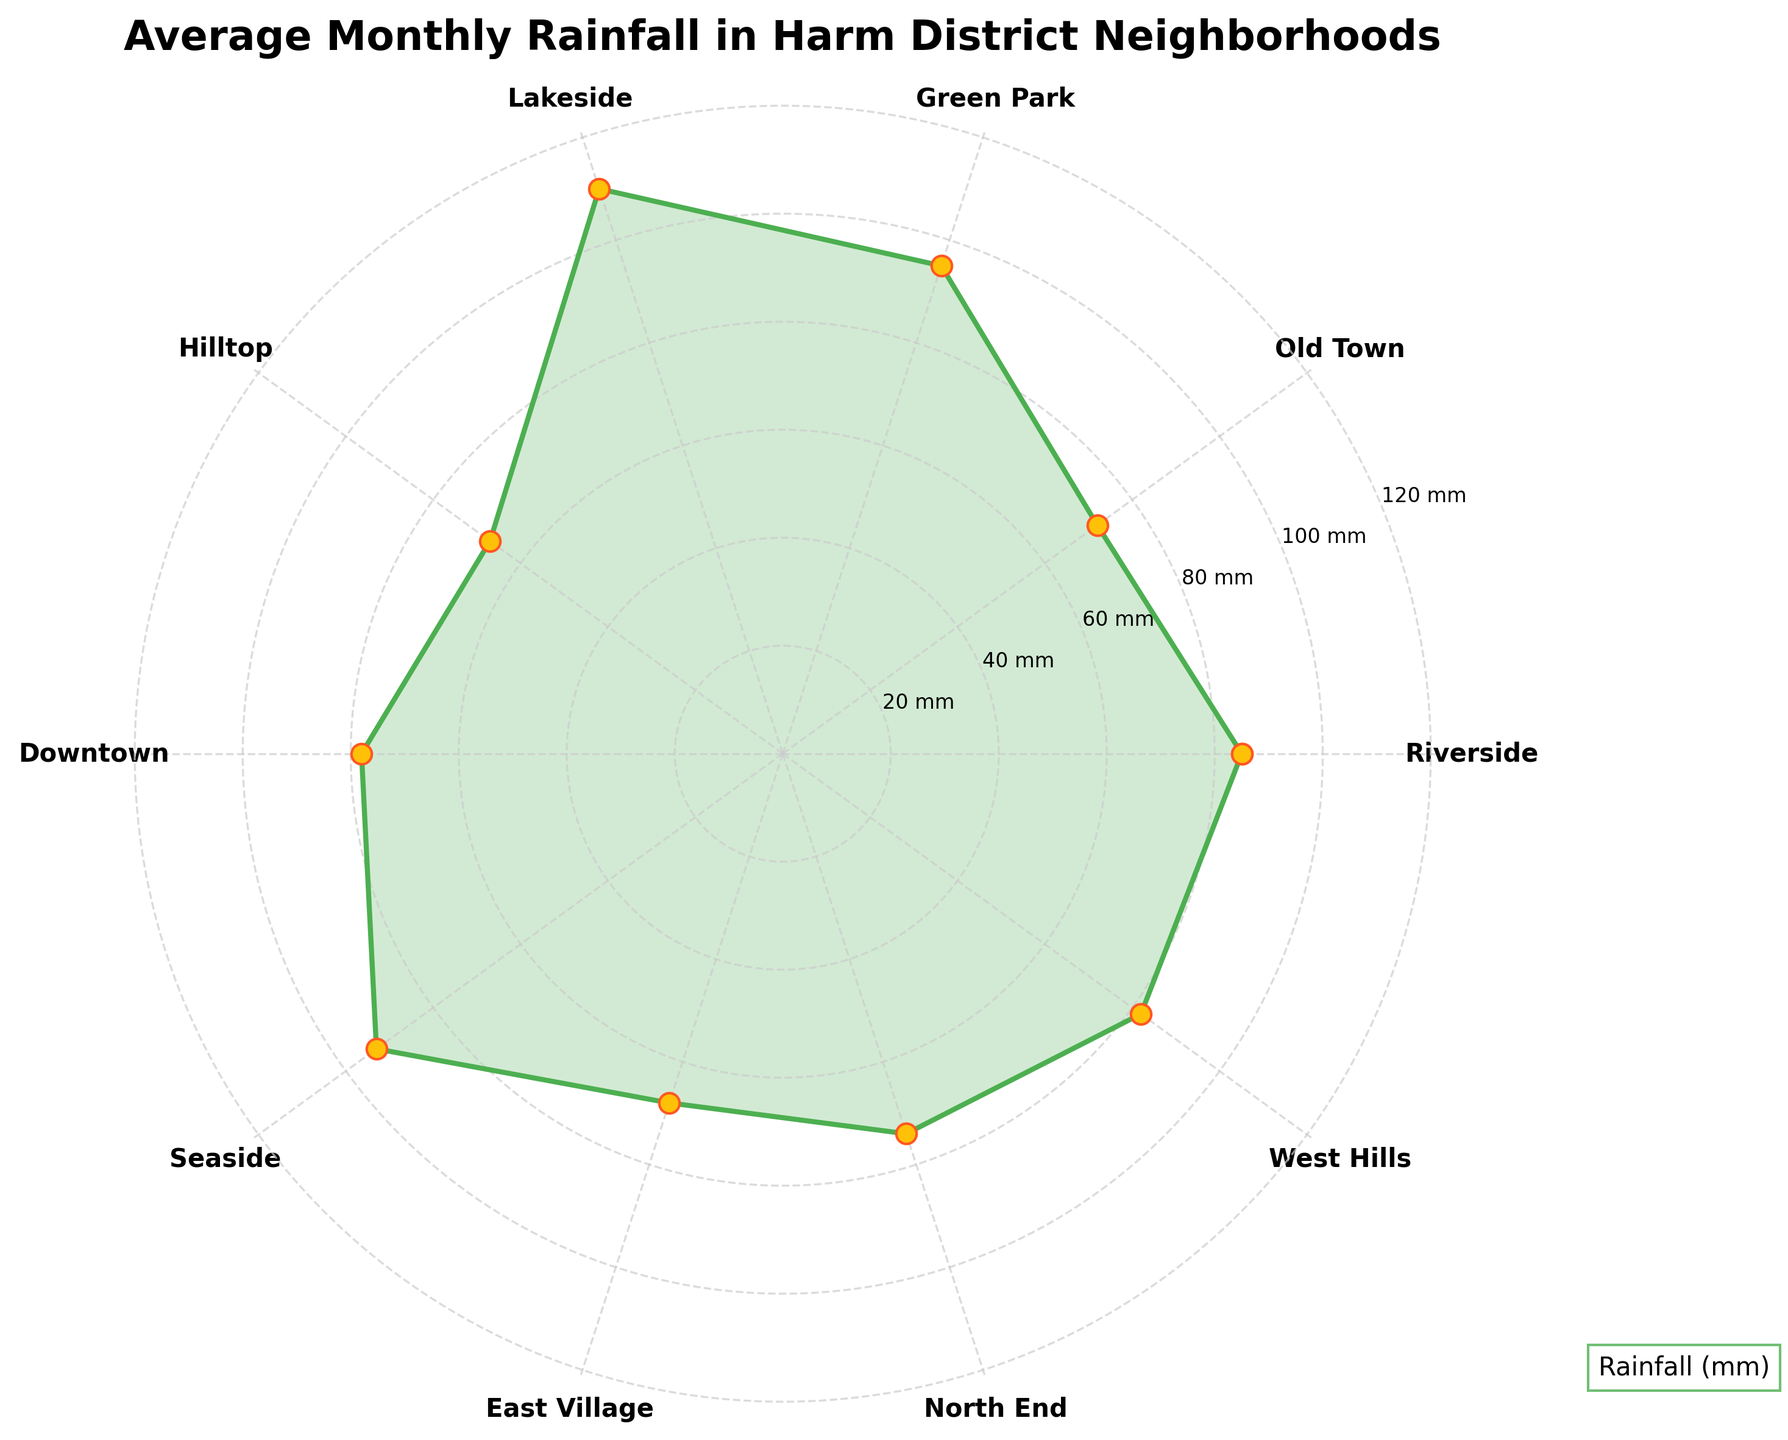What's the title of the figure? The title is displayed at the top of the polar chart and helps to understand the main subject of the data presented.
Answer: Average Monthly Rainfall in Harm District Neighborhoods Which neighborhood has the highest average monthly rainfall? By visually inspecting the polar chart, we can see that the outermost point (farthest from the center) represents the highest value. Lakeside's point is the farthest from the center.
Answer: Lakeside What is the average monthly rainfall in Hilltop? From the chart, locate Hilltop on the circular axis, then follow the radial line to find the corresponding rainfall value. Hilltop's point is at approximately 67 mm.
Answer: 67 mm What are the neighborhoods with average monthly rainfall less than 70 mm? We need to find all points within the inner circle below 70 mm. Only Hilltop and East Village have points below this value.
Answer: Hilltop, East Village Which neighborhood has more rainfall, Seaside or Downtown? Compare the radial lengths of Seaside and Downtown. The point for Seaside is farther from the center than Downtown.
Answer: Seaside What's the difference in average monthly rainfall between Riverside and West Hills? Identify Riverside and West Hills on the chart and find their rainfall values. Riverside is 85 mm, and West Hills is 82 mm, so the difference is 85 - 82 = 3 mm.
Answer: 3 mm What's the average rainfalls of Riverside, Old Town, and Green Park? Compute the average of the rainfall values of these neighborhoods: (85 + 72 + 95) / 3 = 84 mm.
Answer: 84 mm Which neighborhood is closest to having 80 mm of average monthly rainfall without exceeding it? We need to find the nearest but not exceeding 80 mm among the neighborhoods. Downtown with 78 mm fits this criterion.
Answer: Downtown How many neighborhoods have rainfall more than 90 mm? Count all points beyond the 90 mm circle. Lakeside, Green Park, and Seaside exceed 90 mm.
Answer: 3 What is the total average monthly rainfall for the neighborhoods with names starting with "S"? Identify Seaside, sum their rainfall value 93 mm. There is only one.
Answer: 93 mm 